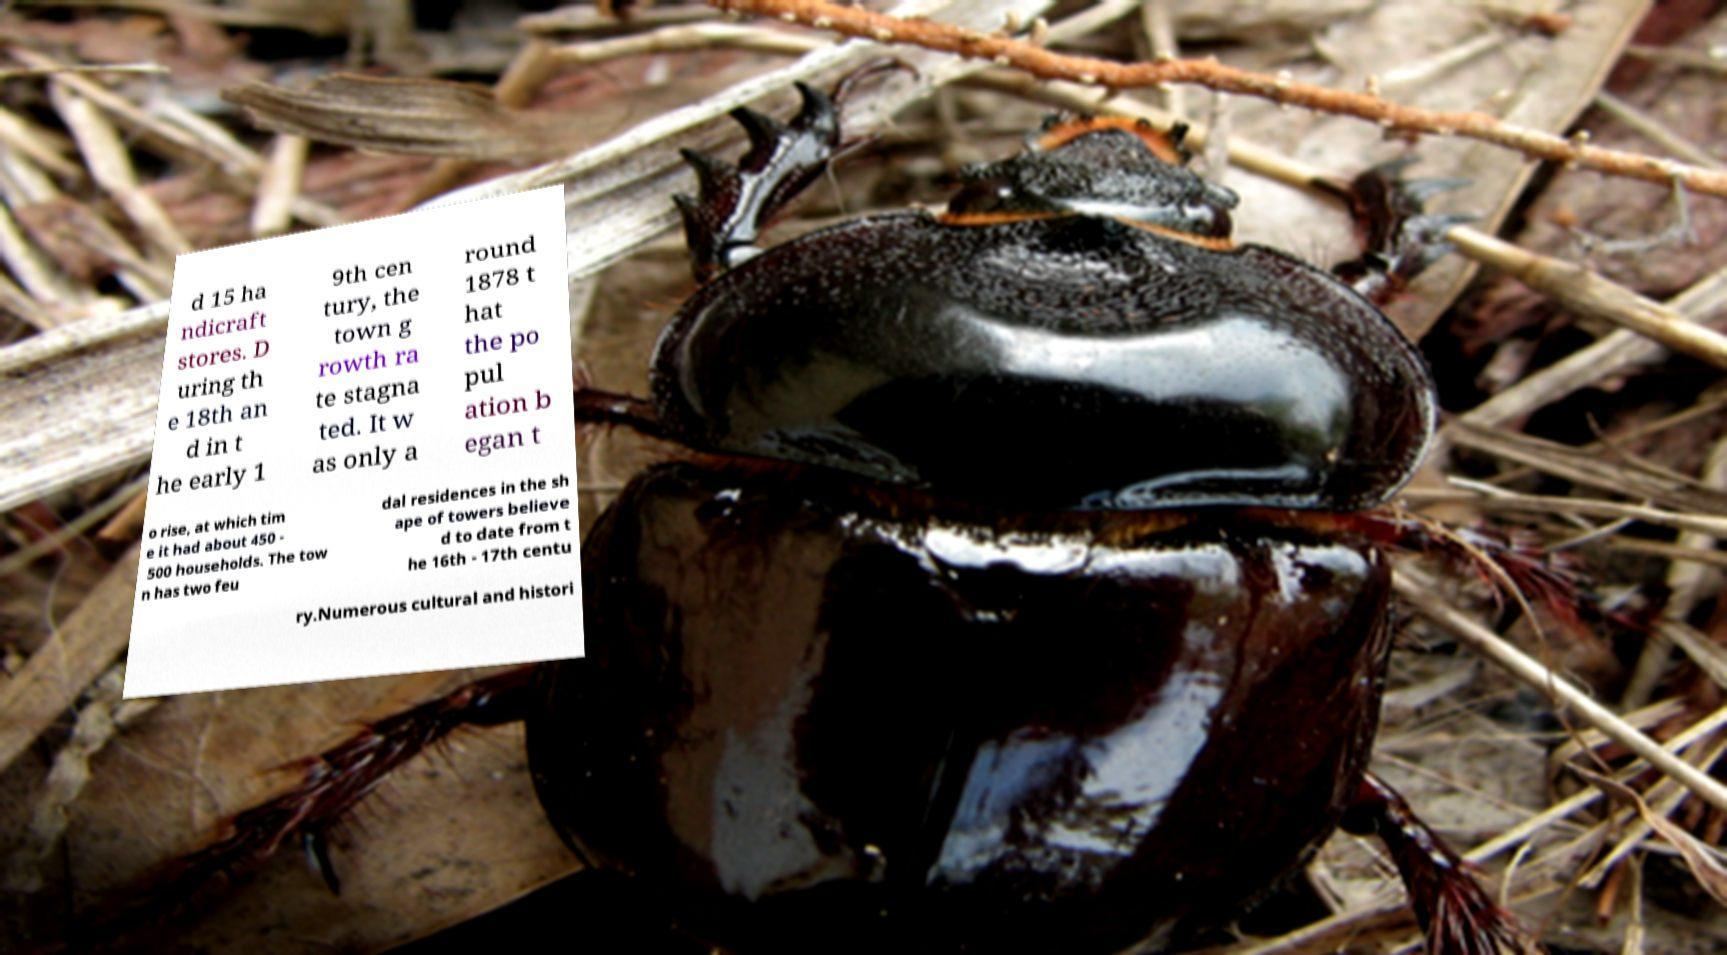Can you accurately transcribe the text from the provided image for me? d 15 ha ndicraft stores. D uring th e 18th an d in t he early 1 9th cen tury, the town g rowth ra te stagna ted. It w as only a round 1878 t hat the po pul ation b egan t o rise, at which tim e it had about 450 - 500 households. The tow n has two feu dal residences in the sh ape of towers believe d to date from t he 16th - 17th centu ry.Numerous cultural and histori 